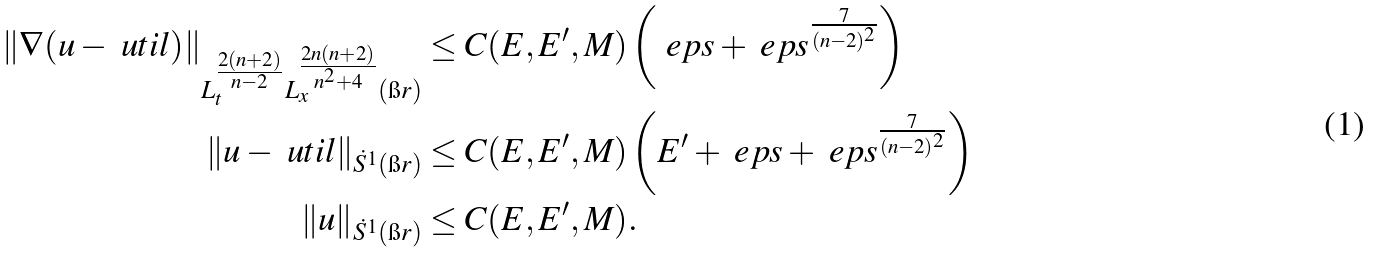<formula> <loc_0><loc_0><loc_500><loc_500>\| \nabla ( u - \ u t i l ) \| _ { L _ { t } ^ { \frac { 2 ( n + 2 ) } { n - 2 } } L _ { x } ^ { \frac { 2 n ( n + 2 ) } { n ^ { 2 } + 4 } } ( \i r ) } & \leq C ( E , E ^ { \prime } , M ) \left ( \ e p s + \ e p s ^ { \frac { 7 } { ( n - 2 ) ^ { 2 } } } \right ) \\ \| u - \ u t i l \| _ { \dot { S } ^ { 1 } ( \i r ) } & \leq C ( E , E ^ { \prime } , M ) \left ( E ^ { \prime } + \ e p s + \ e p s ^ { \frac { 7 } { ( n - 2 ) ^ { 2 } } } \right ) \\ \| u \| _ { \dot { S } ^ { 1 } ( \i r ) } & \leq C ( E , E ^ { \prime } , M ) .</formula> 